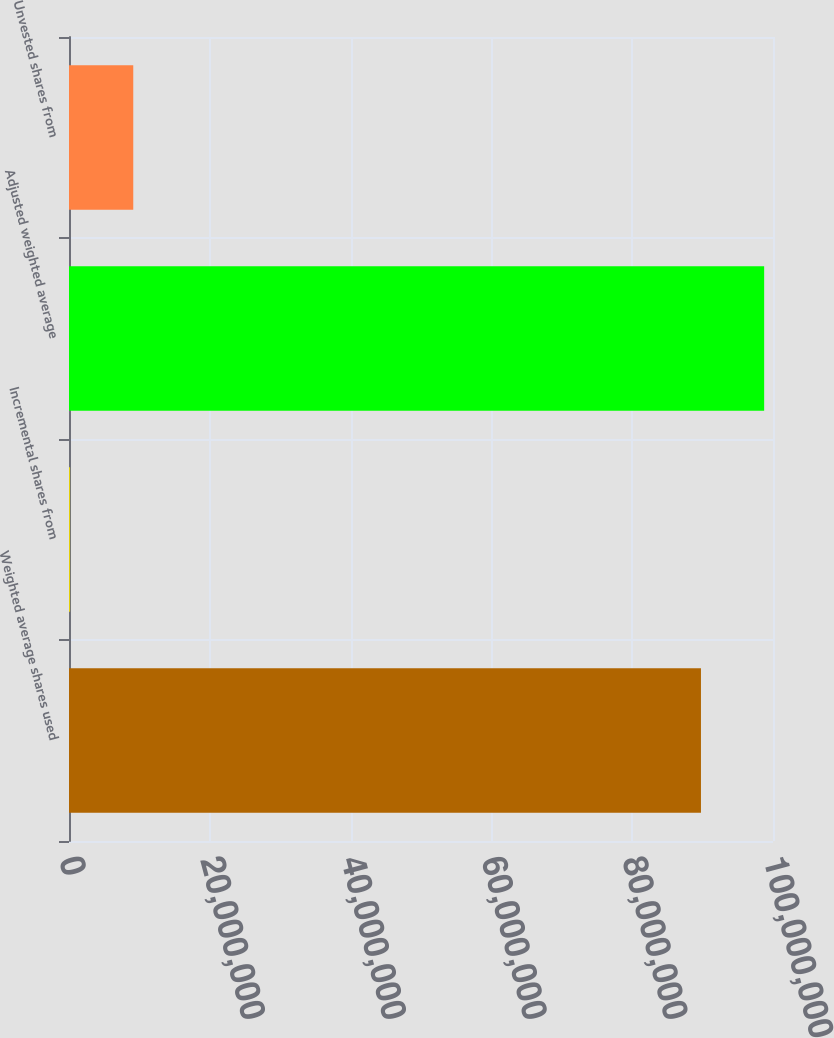Convert chart to OTSL. <chart><loc_0><loc_0><loc_500><loc_500><bar_chart><fcel>Weighted average shares used<fcel>Incremental shares from<fcel>Adjusted weighted average<fcel>Unvested shares from<nl><fcel>8.97667e+07<fcel>150840<fcel>9.87434e+07<fcel>9.12751e+06<nl></chart> 